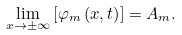Convert formula to latex. <formula><loc_0><loc_0><loc_500><loc_500>\underset { x \rightarrow \pm \infty } { \lim } \left [ \varphi _ { m } \left ( x , t \right ) \right ] = A _ { m } .</formula> 